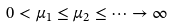Convert formula to latex. <formula><loc_0><loc_0><loc_500><loc_500>0 < \mu _ { 1 } \leq \mu _ { 2 } \leq \dots \to \infty</formula> 